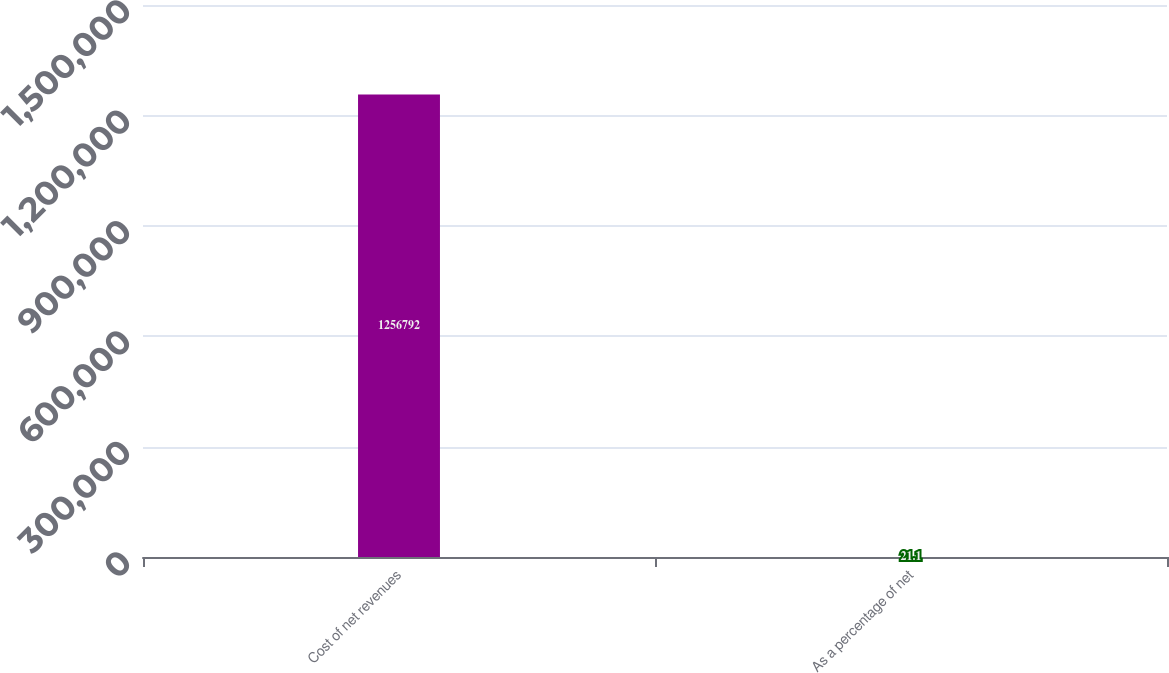<chart> <loc_0><loc_0><loc_500><loc_500><bar_chart><fcel>Cost of net revenues<fcel>As a percentage of net<nl><fcel>1.25679e+06<fcel>21.1<nl></chart> 